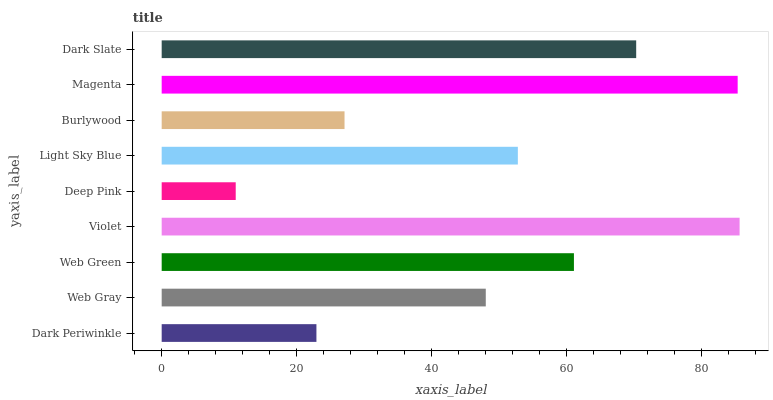Is Deep Pink the minimum?
Answer yes or no. Yes. Is Violet the maximum?
Answer yes or no. Yes. Is Web Gray the minimum?
Answer yes or no. No. Is Web Gray the maximum?
Answer yes or no. No. Is Web Gray greater than Dark Periwinkle?
Answer yes or no. Yes. Is Dark Periwinkle less than Web Gray?
Answer yes or no. Yes. Is Dark Periwinkle greater than Web Gray?
Answer yes or no. No. Is Web Gray less than Dark Periwinkle?
Answer yes or no. No. Is Light Sky Blue the high median?
Answer yes or no. Yes. Is Light Sky Blue the low median?
Answer yes or no. Yes. Is Dark Slate the high median?
Answer yes or no. No. Is Web Green the low median?
Answer yes or no. No. 